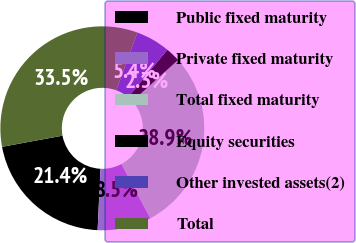<chart> <loc_0><loc_0><loc_500><loc_500><pie_chart><fcel>Public fixed maturity<fcel>Private fixed maturity<fcel>Total fixed maturity<fcel>Equity securities<fcel>Other invested assets(2)<fcel>Total<nl><fcel>21.36%<fcel>8.55%<fcel>28.87%<fcel>2.31%<fcel>5.43%<fcel>33.49%<nl></chart> 